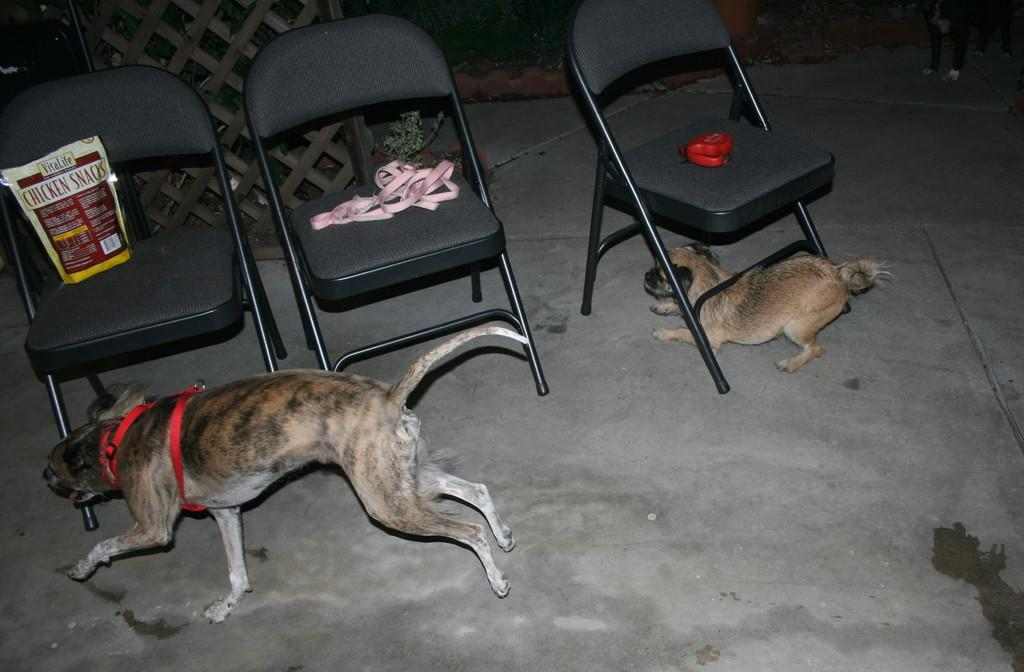How many dogs are present in the image? There are two dogs in the image. Where are the dogs located in the image? The dogs are under a chair. What is attached to the top of the chairs? There is a leash at the top of the chairs. What else can be seen at the top of the chairs besides the leash? There is a food item and an object at the top of the chairs. What type of coal is being used to clean the baby's clothes in the image? There is no coal, baby, or linen present in the image. 